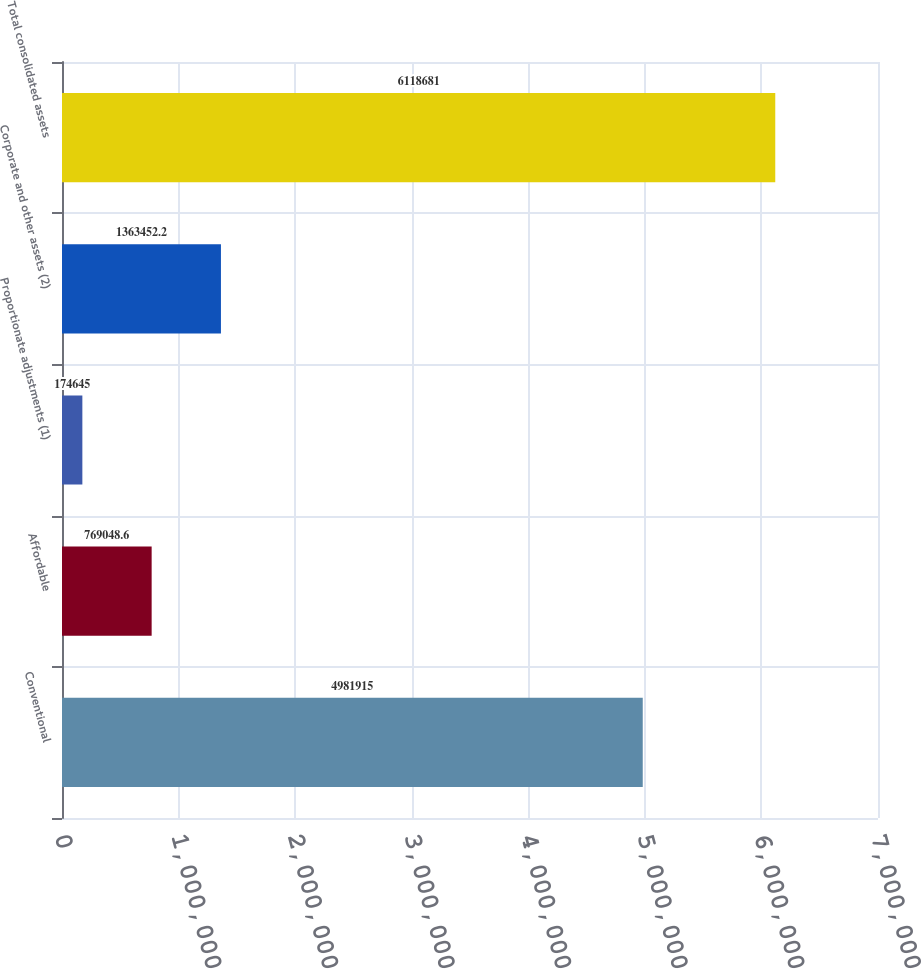Convert chart to OTSL. <chart><loc_0><loc_0><loc_500><loc_500><bar_chart><fcel>Conventional<fcel>Affordable<fcel>Proportionate adjustments (1)<fcel>Corporate and other assets (2)<fcel>Total consolidated assets<nl><fcel>4.98192e+06<fcel>769049<fcel>174645<fcel>1.36345e+06<fcel>6.11868e+06<nl></chart> 